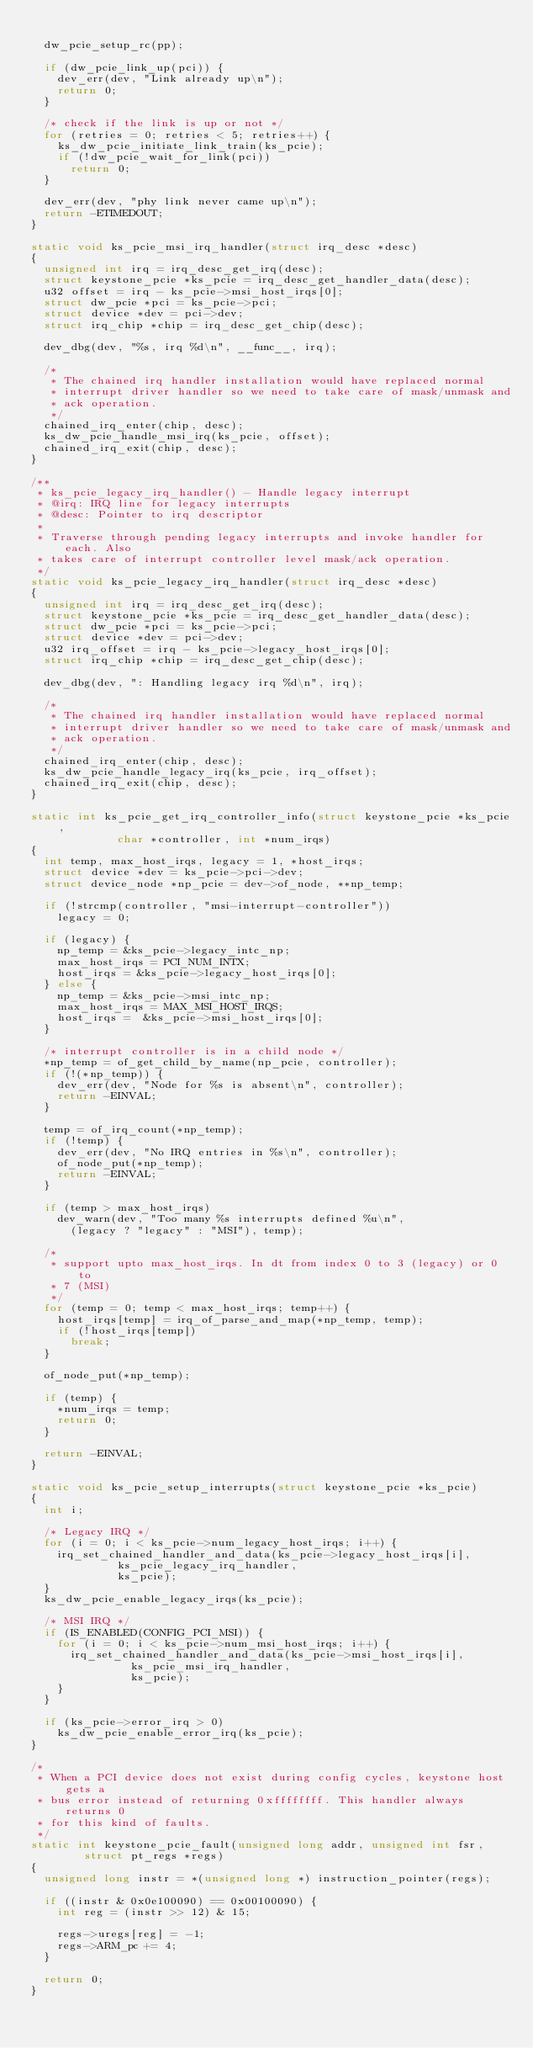<code> <loc_0><loc_0><loc_500><loc_500><_C_>
	dw_pcie_setup_rc(pp);

	if (dw_pcie_link_up(pci)) {
		dev_err(dev, "Link already up\n");
		return 0;
	}

	/* check if the link is up or not */
	for (retries = 0; retries < 5; retries++) {
		ks_dw_pcie_initiate_link_train(ks_pcie);
		if (!dw_pcie_wait_for_link(pci))
			return 0;
	}

	dev_err(dev, "phy link never came up\n");
	return -ETIMEDOUT;
}

static void ks_pcie_msi_irq_handler(struct irq_desc *desc)
{
	unsigned int irq = irq_desc_get_irq(desc);
	struct keystone_pcie *ks_pcie = irq_desc_get_handler_data(desc);
	u32 offset = irq - ks_pcie->msi_host_irqs[0];
	struct dw_pcie *pci = ks_pcie->pci;
	struct device *dev = pci->dev;
	struct irq_chip *chip = irq_desc_get_chip(desc);

	dev_dbg(dev, "%s, irq %d\n", __func__, irq);

	/*
	 * The chained irq handler installation would have replaced normal
	 * interrupt driver handler so we need to take care of mask/unmask and
	 * ack operation.
	 */
	chained_irq_enter(chip, desc);
	ks_dw_pcie_handle_msi_irq(ks_pcie, offset);
	chained_irq_exit(chip, desc);
}

/**
 * ks_pcie_legacy_irq_handler() - Handle legacy interrupt
 * @irq: IRQ line for legacy interrupts
 * @desc: Pointer to irq descriptor
 *
 * Traverse through pending legacy interrupts and invoke handler for each. Also
 * takes care of interrupt controller level mask/ack operation.
 */
static void ks_pcie_legacy_irq_handler(struct irq_desc *desc)
{
	unsigned int irq = irq_desc_get_irq(desc);
	struct keystone_pcie *ks_pcie = irq_desc_get_handler_data(desc);
	struct dw_pcie *pci = ks_pcie->pci;
	struct device *dev = pci->dev;
	u32 irq_offset = irq - ks_pcie->legacy_host_irqs[0];
	struct irq_chip *chip = irq_desc_get_chip(desc);

	dev_dbg(dev, ": Handling legacy irq %d\n", irq);

	/*
	 * The chained irq handler installation would have replaced normal
	 * interrupt driver handler so we need to take care of mask/unmask and
	 * ack operation.
	 */
	chained_irq_enter(chip, desc);
	ks_dw_pcie_handle_legacy_irq(ks_pcie, irq_offset);
	chained_irq_exit(chip, desc);
}

static int ks_pcie_get_irq_controller_info(struct keystone_pcie *ks_pcie,
					   char *controller, int *num_irqs)
{
	int temp, max_host_irqs, legacy = 1, *host_irqs;
	struct device *dev = ks_pcie->pci->dev;
	struct device_node *np_pcie = dev->of_node, **np_temp;

	if (!strcmp(controller, "msi-interrupt-controller"))
		legacy = 0;

	if (legacy) {
		np_temp = &ks_pcie->legacy_intc_np;
		max_host_irqs = PCI_NUM_INTX;
		host_irqs = &ks_pcie->legacy_host_irqs[0];
	} else {
		np_temp = &ks_pcie->msi_intc_np;
		max_host_irqs = MAX_MSI_HOST_IRQS;
		host_irqs =  &ks_pcie->msi_host_irqs[0];
	}

	/* interrupt controller is in a child node */
	*np_temp = of_get_child_by_name(np_pcie, controller);
	if (!(*np_temp)) {
		dev_err(dev, "Node for %s is absent\n", controller);
		return -EINVAL;
	}

	temp = of_irq_count(*np_temp);
	if (!temp) {
		dev_err(dev, "No IRQ entries in %s\n", controller);
		of_node_put(*np_temp);
		return -EINVAL;
	}

	if (temp > max_host_irqs)
		dev_warn(dev, "Too many %s interrupts defined %u\n",
			(legacy ? "legacy" : "MSI"), temp);

	/*
	 * support upto max_host_irqs. In dt from index 0 to 3 (legacy) or 0 to
	 * 7 (MSI)
	 */
	for (temp = 0; temp < max_host_irqs; temp++) {
		host_irqs[temp] = irq_of_parse_and_map(*np_temp, temp);
		if (!host_irqs[temp])
			break;
	}

	of_node_put(*np_temp);

	if (temp) {
		*num_irqs = temp;
		return 0;
	}

	return -EINVAL;
}

static void ks_pcie_setup_interrupts(struct keystone_pcie *ks_pcie)
{
	int i;

	/* Legacy IRQ */
	for (i = 0; i < ks_pcie->num_legacy_host_irqs; i++) {
		irq_set_chained_handler_and_data(ks_pcie->legacy_host_irqs[i],
						 ks_pcie_legacy_irq_handler,
						 ks_pcie);
	}
	ks_dw_pcie_enable_legacy_irqs(ks_pcie);

	/* MSI IRQ */
	if (IS_ENABLED(CONFIG_PCI_MSI)) {
		for (i = 0; i < ks_pcie->num_msi_host_irqs; i++) {
			irq_set_chained_handler_and_data(ks_pcie->msi_host_irqs[i],
							 ks_pcie_msi_irq_handler,
							 ks_pcie);
		}
	}

	if (ks_pcie->error_irq > 0)
		ks_dw_pcie_enable_error_irq(ks_pcie);
}

/*
 * When a PCI device does not exist during config cycles, keystone host gets a
 * bus error instead of returning 0xffffffff. This handler always returns 0
 * for this kind of faults.
 */
static int keystone_pcie_fault(unsigned long addr, unsigned int fsr,
				struct pt_regs *regs)
{
	unsigned long instr = *(unsigned long *) instruction_pointer(regs);

	if ((instr & 0x0e100090) == 0x00100090) {
		int reg = (instr >> 12) & 15;

		regs->uregs[reg] = -1;
		regs->ARM_pc += 4;
	}

	return 0;
}
</code> 